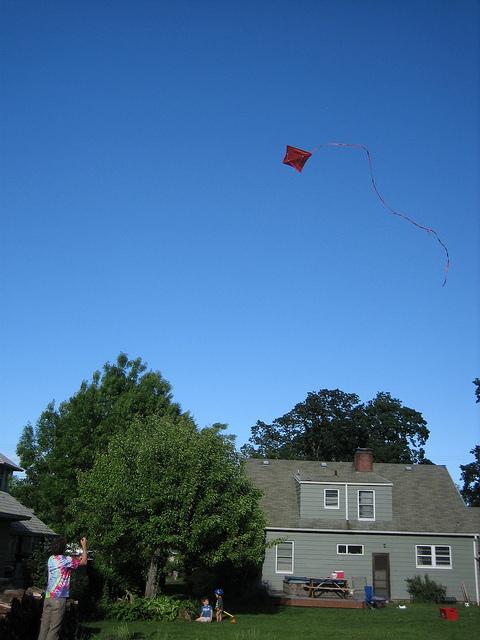Which kite is furthest away?
Concise answer only. Red. Is the building white?
Keep it brief. No. What are the boys on the roof doing?
Short answer required. Flying kite. Where is the picnic bench located?
Short answer required. Backyard. What is the man doing?
Write a very short answer. Flying kite. Are there any clouds in the sky?
Keep it brief. No. What color is the roof?
Answer briefly. Gray. What is on the roof of the house?
Keep it brief. Chimney. Have you ever seen such a kite?
Give a very brief answer. Yes. Is this a governmental building?
Keep it brief. No. Where is the scene set?
Give a very brief answer. Backyard. What design is the man's shirt?
Answer briefly. Tie dye. How many satellite dishes are on the house?
Quick response, please. 0. What color is the sky?
Concise answer only. Blue. Are there clouds?
Give a very brief answer. No. 